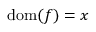<formula> <loc_0><loc_0><loc_500><loc_500>{ d o m } ( f ) = x</formula> 